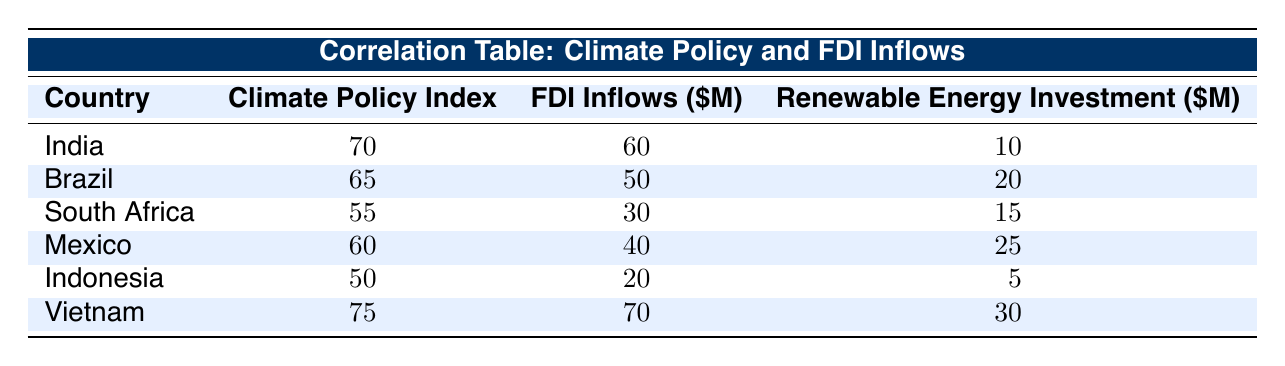What is the climate policy index of Vietnam? The table indicates that Vietnam has a climate policy index of 75.
Answer: 75 What is the FDI inflow amount for Brazil? According to the table, Brazil's FDI inflows amount to 50 million USD.
Answer: 50 million USD Which country has the highest renewable energy investment? By examining the renewable energy investment column, Vietnam has the highest investment of 30 million USD, compared to the others.
Answer: Vietnam What is the average FDI inflow for the countries listed? To calculate the average, sum the FDI inflows: 60 + 50 + 30 + 40 + 20 + 70 = 270. There are 6 countries, so the average is 270 / 6 = 45 million USD.
Answer: 45 million USD Is there a country with a climate policy index below 55? Yes, Indonesia has a climate policy index of 50, which is below 55.
Answer: Yes Which country has the second lowest FDI inflows? The FDI inflow amounts are sorted as follows: Vietnam (70), India (60), Brazil (50), Mexico (40), South Africa (30), and Indonesia (20). The second lowest is South Africa with 30 million USD.
Answer: South Africa What is the difference in FDI inflows between India and Indonesia? The FDI inflow for India is 60 million USD and for Indonesia it is 20 million USD. The difference is 60 - 20 = 40 million USD.
Answer: 40 million USD Are the FDI inflows directly correlated with the climate policy index in this data? Based on the data, countries with higher climate policy indexes generally have higher FDI inflows, but correlation can only be definitively determined with statistical analysis. For the given data, there appears to be a positive correlation.
Answer: Yes If the renewable energy investment in Mexico increases by 10 million USD, what will be its new total? Mexico currently has a renewable energy investment of 25 million USD. If it increases by 10 million USD, the new total will be 25 + 10 = 35 million USD.
Answer: 35 million USD 